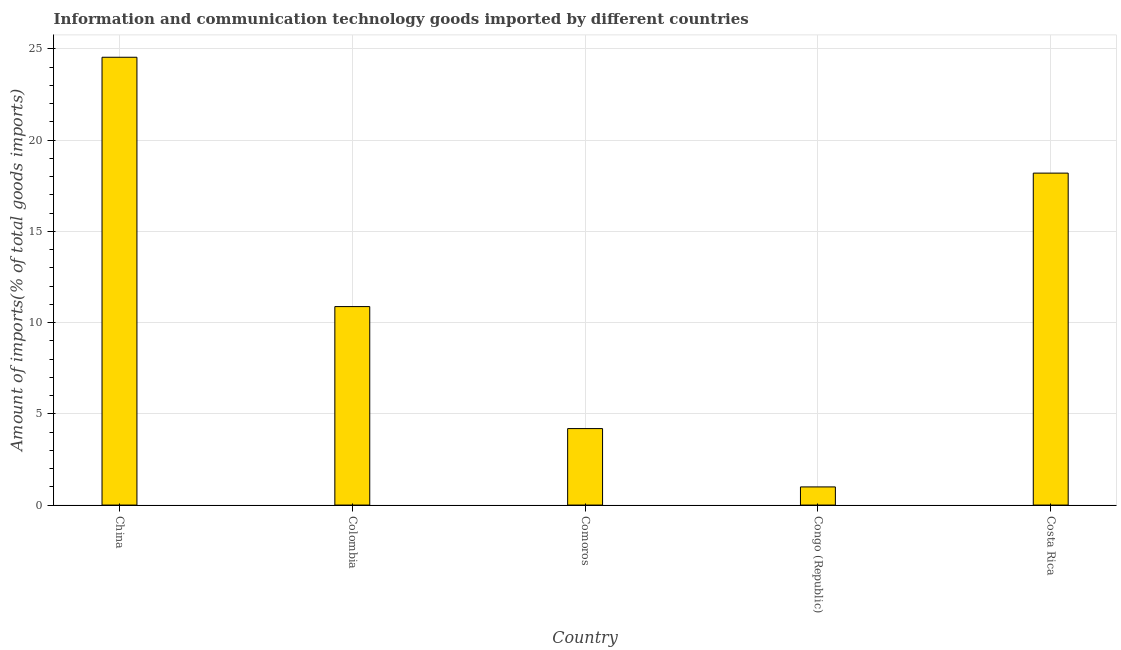What is the title of the graph?
Your answer should be very brief. Information and communication technology goods imported by different countries. What is the label or title of the X-axis?
Offer a terse response. Country. What is the label or title of the Y-axis?
Offer a very short reply. Amount of imports(% of total goods imports). What is the amount of ict goods imports in Congo (Republic)?
Ensure brevity in your answer.  1. Across all countries, what is the maximum amount of ict goods imports?
Provide a succinct answer. 24.55. Across all countries, what is the minimum amount of ict goods imports?
Make the answer very short. 1. In which country was the amount of ict goods imports minimum?
Make the answer very short. Congo (Republic). What is the sum of the amount of ict goods imports?
Your answer should be compact. 58.81. What is the difference between the amount of ict goods imports in Comoros and Congo (Republic)?
Offer a very short reply. 3.2. What is the average amount of ict goods imports per country?
Provide a succinct answer. 11.76. What is the median amount of ict goods imports?
Make the answer very short. 10.88. In how many countries, is the amount of ict goods imports greater than 1 %?
Keep it short and to the point. 4. What is the ratio of the amount of ict goods imports in China to that in Comoros?
Give a very brief answer. 5.85. What is the difference between the highest and the second highest amount of ict goods imports?
Make the answer very short. 6.35. What is the difference between the highest and the lowest amount of ict goods imports?
Provide a succinct answer. 23.55. What is the difference between two consecutive major ticks on the Y-axis?
Your answer should be very brief. 5. Are the values on the major ticks of Y-axis written in scientific E-notation?
Your answer should be very brief. No. What is the Amount of imports(% of total goods imports) in China?
Offer a terse response. 24.55. What is the Amount of imports(% of total goods imports) of Colombia?
Offer a terse response. 10.88. What is the Amount of imports(% of total goods imports) of Comoros?
Provide a succinct answer. 4.19. What is the Amount of imports(% of total goods imports) in Congo (Republic)?
Make the answer very short. 1. What is the Amount of imports(% of total goods imports) in Costa Rica?
Offer a terse response. 18.2. What is the difference between the Amount of imports(% of total goods imports) in China and Colombia?
Provide a succinct answer. 13.67. What is the difference between the Amount of imports(% of total goods imports) in China and Comoros?
Keep it short and to the point. 20.35. What is the difference between the Amount of imports(% of total goods imports) in China and Congo (Republic)?
Your response must be concise. 23.55. What is the difference between the Amount of imports(% of total goods imports) in China and Costa Rica?
Make the answer very short. 6.35. What is the difference between the Amount of imports(% of total goods imports) in Colombia and Comoros?
Provide a short and direct response. 6.69. What is the difference between the Amount of imports(% of total goods imports) in Colombia and Congo (Republic)?
Offer a terse response. 9.88. What is the difference between the Amount of imports(% of total goods imports) in Colombia and Costa Rica?
Your answer should be compact. -7.32. What is the difference between the Amount of imports(% of total goods imports) in Comoros and Congo (Republic)?
Ensure brevity in your answer.  3.2. What is the difference between the Amount of imports(% of total goods imports) in Comoros and Costa Rica?
Your response must be concise. -14. What is the difference between the Amount of imports(% of total goods imports) in Congo (Republic) and Costa Rica?
Offer a terse response. -17.2. What is the ratio of the Amount of imports(% of total goods imports) in China to that in Colombia?
Provide a short and direct response. 2.26. What is the ratio of the Amount of imports(% of total goods imports) in China to that in Comoros?
Offer a terse response. 5.85. What is the ratio of the Amount of imports(% of total goods imports) in China to that in Congo (Republic)?
Your answer should be very brief. 24.66. What is the ratio of the Amount of imports(% of total goods imports) in China to that in Costa Rica?
Your response must be concise. 1.35. What is the ratio of the Amount of imports(% of total goods imports) in Colombia to that in Comoros?
Provide a succinct answer. 2.6. What is the ratio of the Amount of imports(% of total goods imports) in Colombia to that in Congo (Republic)?
Make the answer very short. 10.93. What is the ratio of the Amount of imports(% of total goods imports) in Colombia to that in Costa Rica?
Your answer should be very brief. 0.6. What is the ratio of the Amount of imports(% of total goods imports) in Comoros to that in Congo (Republic)?
Your answer should be compact. 4.21. What is the ratio of the Amount of imports(% of total goods imports) in Comoros to that in Costa Rica?
Give a very brief answer. 0.23. What is the ratio of the Amount of imports(% of total goods imports) in Congo (Republic) to that in Costa Rica?
Ensure brevity in your answer.  0.06. 